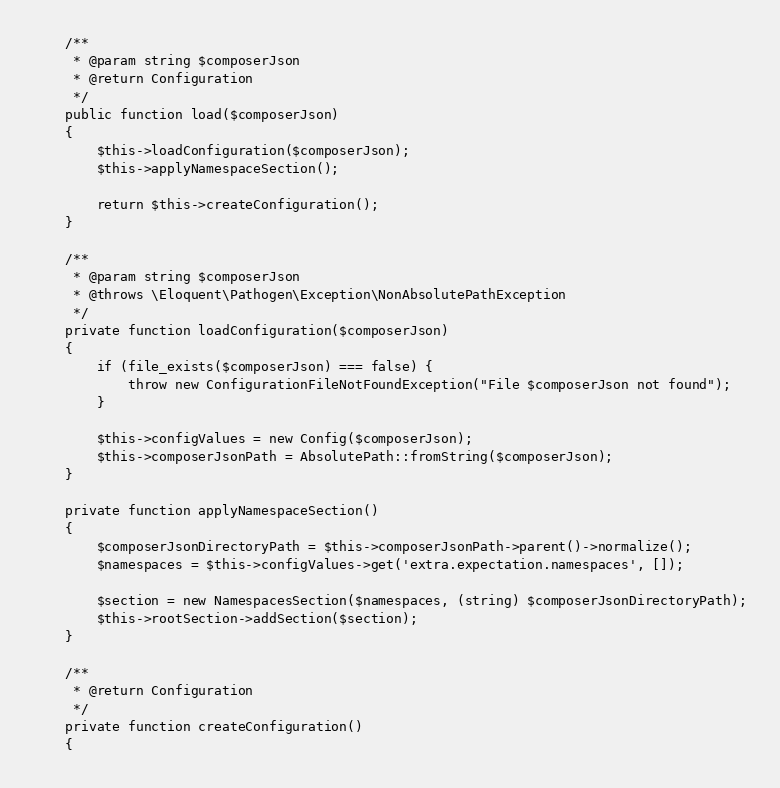<code> <loc_0><loc_0><loc_500><loc_500><_PHP_>
    /**
     * @param string $composerJson
     * @return Configuration
     */
    public function load($composerJson)
    {
        $this->loadConfiguration($composerJson);
        $this->applyNamespaceSection();

        return $this->createConfiguration();
    }

    /**
     * @param string $composerJson
     * @throws \Eloquent\Pathogen\Exception\NonAbsolutePathException
     */
    private function loadConfiguration($composerJson)
    {
        if (file_exists($composerJson) === false) {
            throw new ConfigurationFileNotFoundException("File $composerJson not found");
        }

        $this->configValues = new Config($composerJson);
        $this->composerJsonPath = AbsolutePath::fromString($composerJson);
    }

    private function applyNamespaceSection()
    {
        $composerJsonDirectoryPath = $this->composerJsonPath->parent()->normalize();
        $namespaces = $this->configValues->get('extra.expectation.namespaces', []);

        $section = new NamespacesSection($namespaces, (string) $composerJsonDirectoryPath);
        $this->rootSection->addSection($section);
    }

    /**
     * @return Configuration
     */
    private function createConfiguration()
    {</code> 